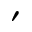Convert formula to latex. <formula><loc_0><loc_0><loc_500><loc_500>^ { \prime }</formula> 